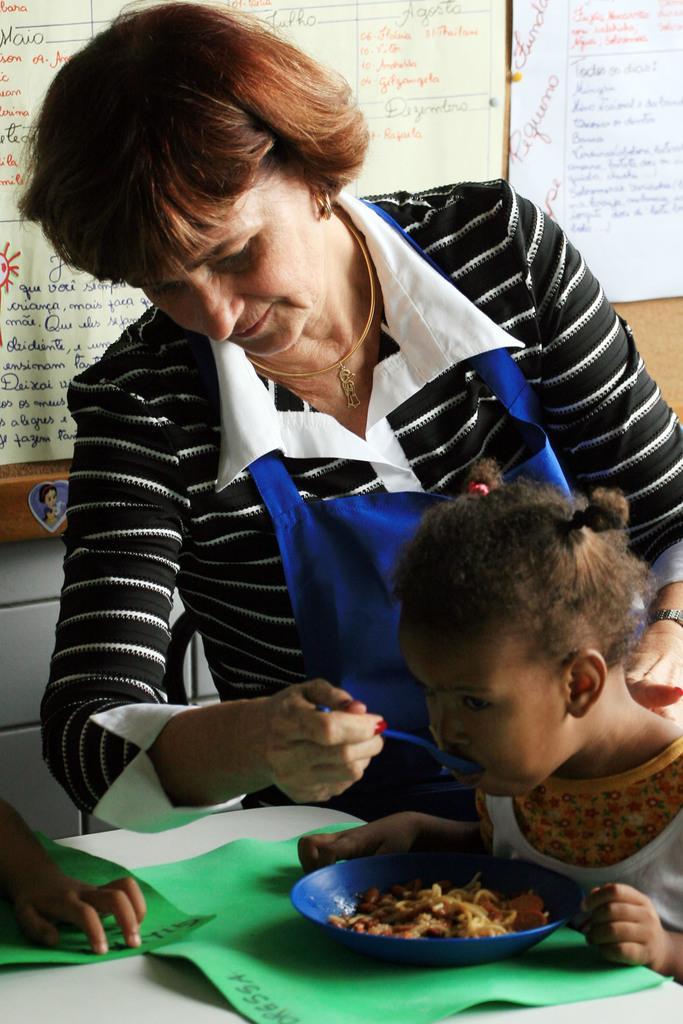Can you describe this image briefly? In this image we can see a girl sitting. At the bottom there is a table and we can see papers and a bowl containing food placed on the table. There is a lady standing and feeding the girl. In the background there are boards placed on the wall. 